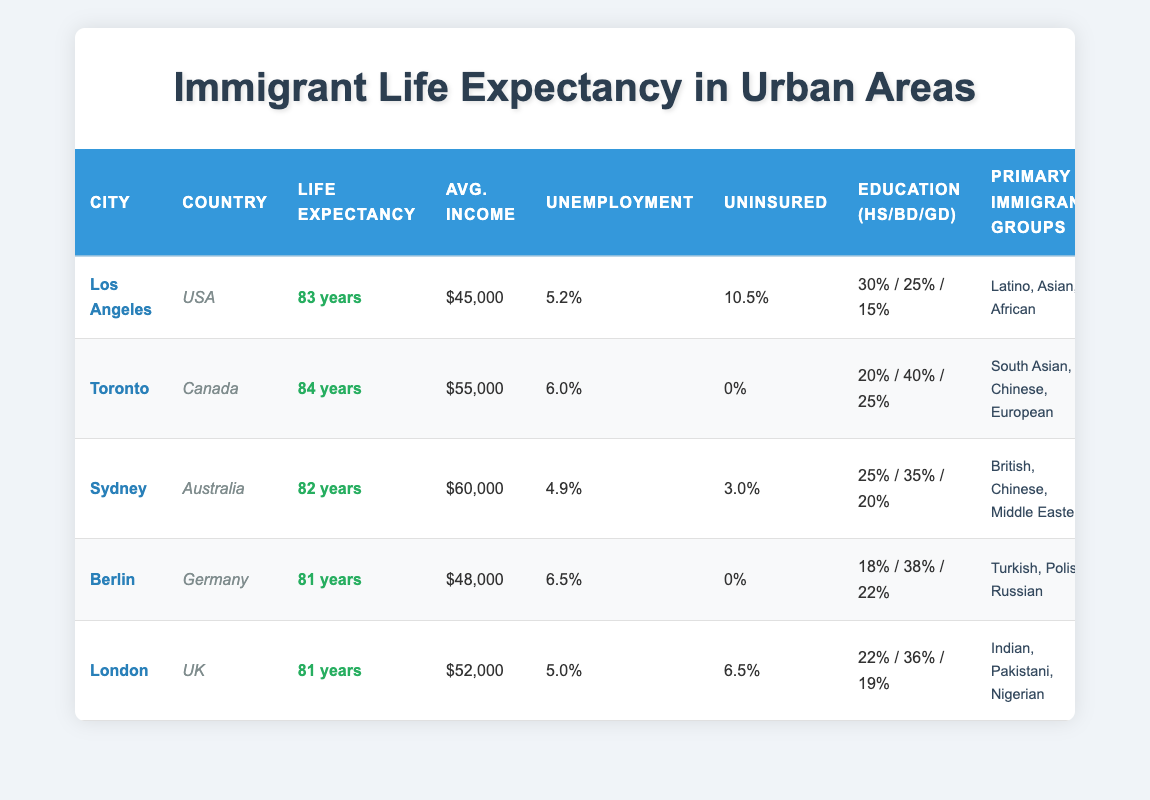What is the life expectancy in Toronto? The life expectancy in Toronto is provided directly in the table under the corresponding row. It states "84 years" for Toronto.
Answer: 84 years Which city has the highest average income? In the table, the average income for each city is listed. Upon comparison, Sydney has the highest average income listed at "$60,000."
Answer: Sydney Is there any city where the percent uninsured is 0%? The table indicates that Toronto and Berlin list the percent uninsured as "0%." Therefore, both cities satisfy the condition.
Answer: Yes What is the average life expectancy of cities in the USA? The average life expectancy for US cities (only Los Angeles in this case) is taken into account. Los Angeles shows "83 years." Since it's the only city in the USA listed, its average life expectancy is 83 years.
Answer: 83 years How does the unemployment rate in Berlin compare to that of London? The table shows the unemployment rate for Berlin as "6.5%" and for London as "5.0%." When comparing, Berlin has a higher unemployment rate than London.
Answer: Berlin has a higher unemployment rate What is the combined average life expectancy of cities in Canada? The only city in Canada in the table is Toronto, with a life expectancy of "84 years." Since there is only one city, the average is simply 84 years.
Answer: 84 years Which primary immigrant group is associated with the highest life expectancy city? The city with the highest life expectancy is Toronto at "84 years," and the primary immigrant groups in that city are "South Asian, Chinese, European."
Answer: South Asian, Chinese, European What percentage of the population has a graduate degree in Los Angeles? The table lists the education level percentages for Los Angeles as 30% with high school, 25% with bachelor's degree, and 15% with graduate degree. Therefore, the percentage with a graduate degree is directly available as "15%."
Answer: 15% Which city has the lowest average life expectancy and what is that expectancy? The table shows that both Berlin and London have the same lowest life expectancy of "81 years." They are compared to find that they are tied for the lowest.
Answer: 81 years 